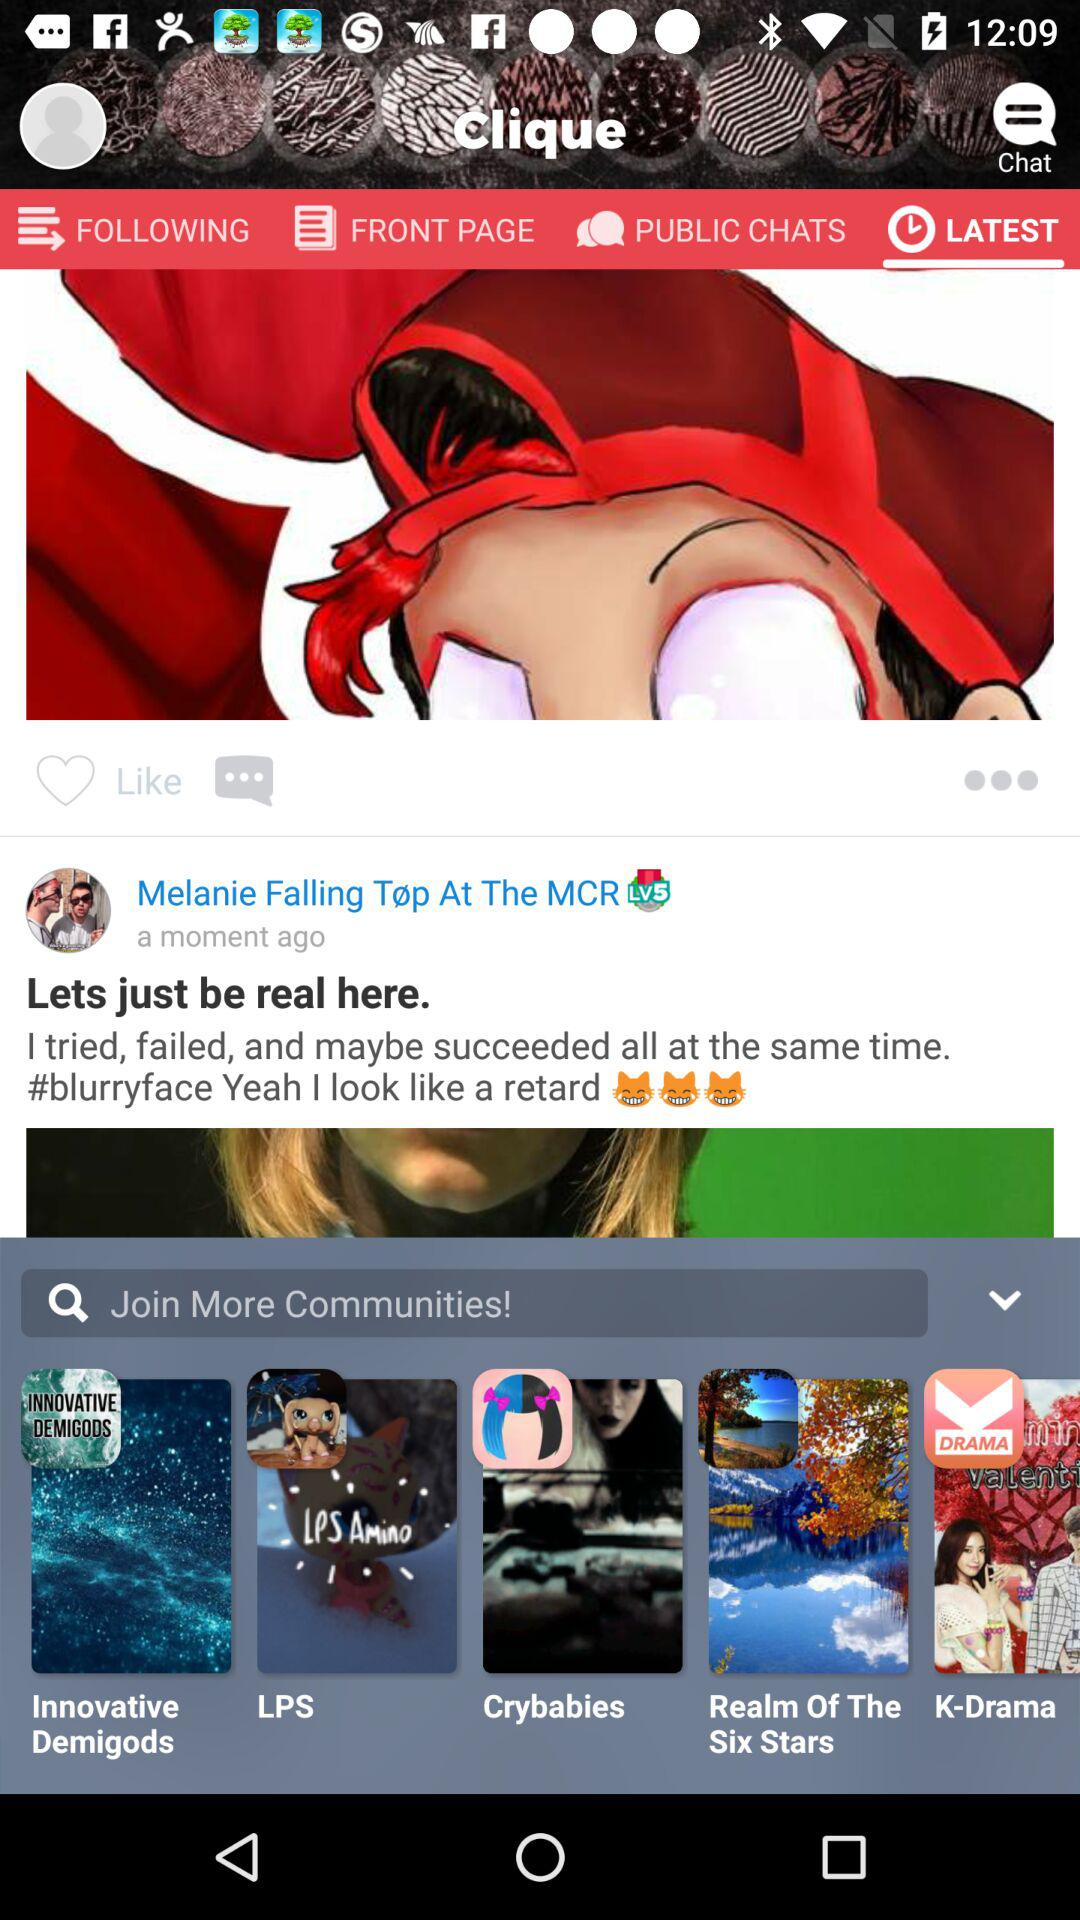When was the post updated? The post was updated a moment ago. 